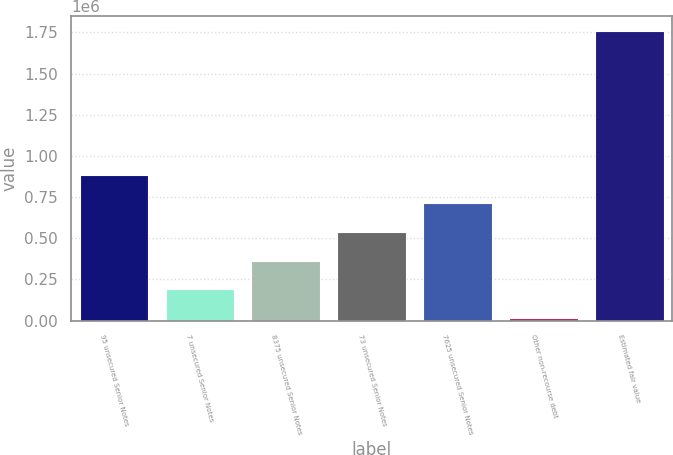Convert chart to OTSL. <chart><loc_0><loc_0><loc_500><loc_500><bar_chart><fcel>95 unsecured Senior Notes<fcel>7 unsecured Senior Notes<fcel>8375 unsecured Senior Notes<fcel>73 unsecured Senior Notes<fcel>7625 unsecured Senior Notes<fcel>Other non-recourse debt<fcel>Estimated fair value<nl><fcel>887368<fcel>189478<fcel>363950<fcel>538423<fcel>712895<fcel>15005<fcel>1.75973e+06<nl></chart> 